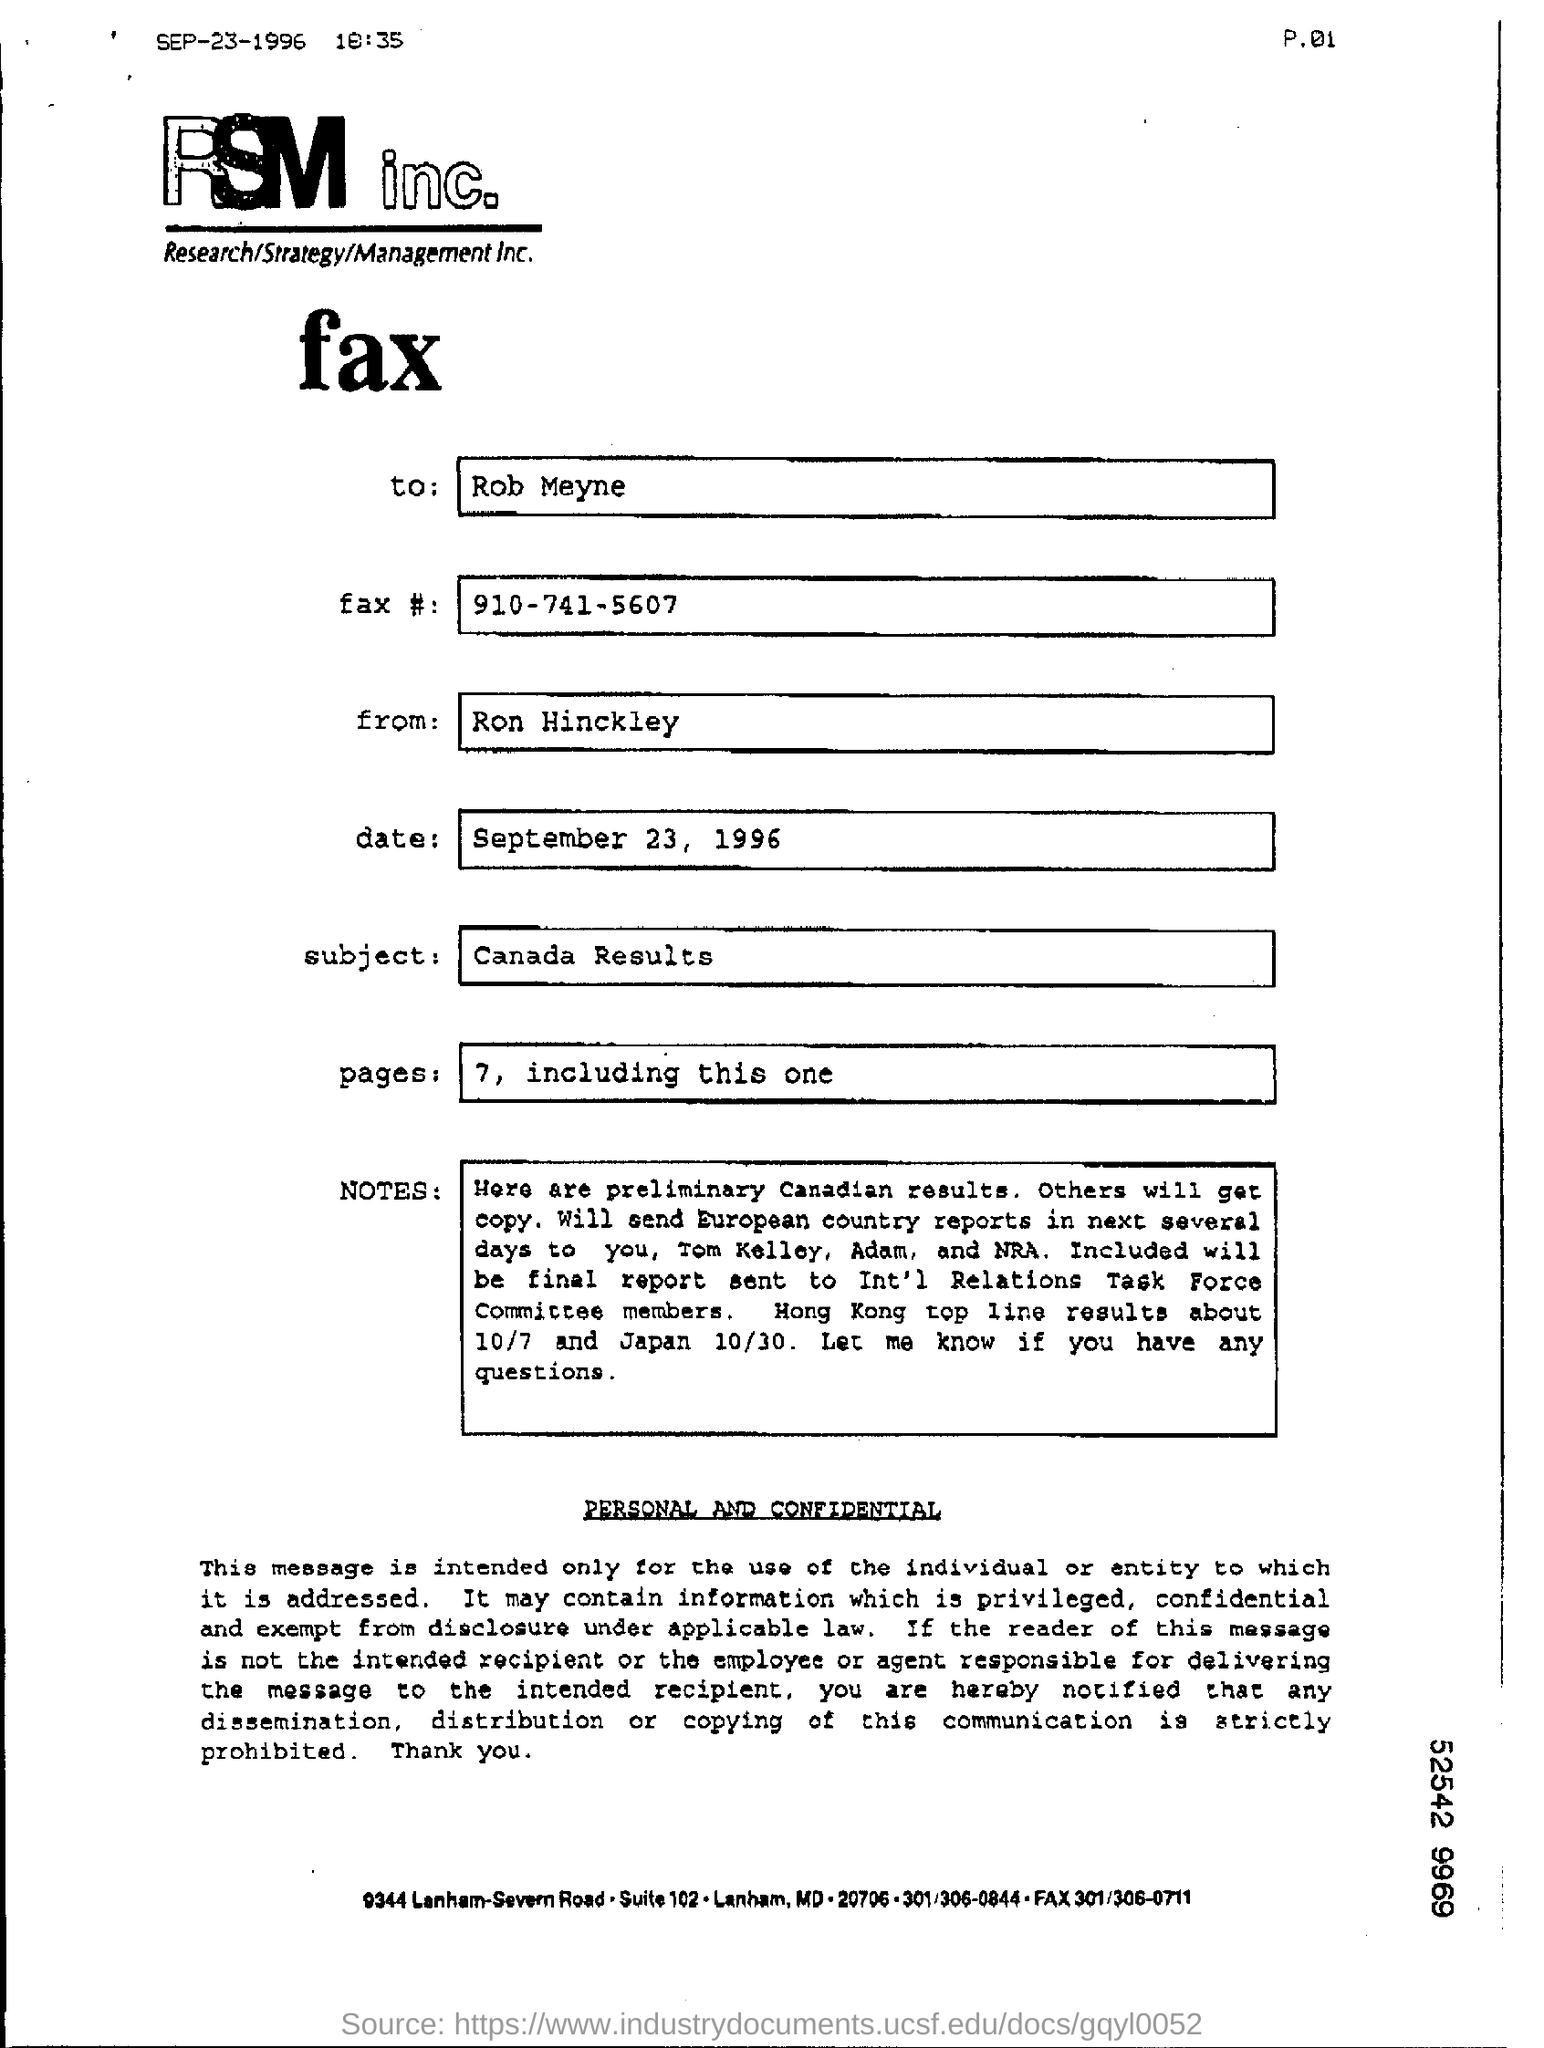Who is the sender of the Fax?
Your answer should be compact. Ron Hinckley. To whom, the Fax is being sent?
Your response must be concise. Rob Meyne. What is the Fax #(no) given ?
Ensure brevity in your answer.  910-741-5607. What is the subject mentioned in the fax?
Keep it short and to the point. Canada results. What is the date mentioned in the fax?
Offer a very short reply. September 23, 1996. 